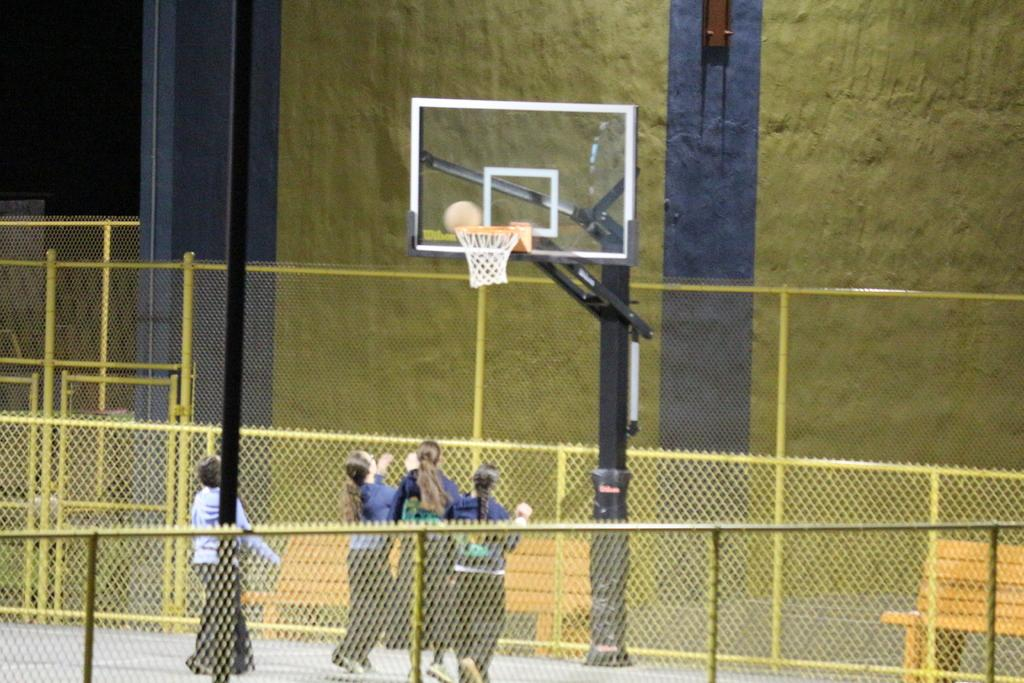What is happening in the image involving the people? There are people standing in the image, which suggests they might be waiting or observing something. What is in front of the people? There is a net, a ball, and a stand in front of the people. What is the purpose of the stand in the image? The purpose of the stand is not clear from the image, but it could be for holding equipment or providing information. What is the color of the fencing around the area? The fencing around the area is yellow. Can you see any steam coming from the sidewalk in the image? There is no sidewalk or steam present in the image. 